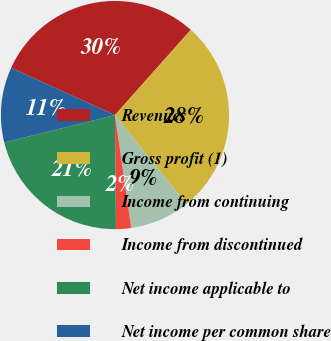Convert chart. <chart><loc_0><loc_0><loc_500><loc_500><pie_chart><fcel>Revenues<fcel>Gross profit (1)<fcel>Income from continuing<fcel>Income from discontinued<fcel>Net income applicable to<fcel>Net income per common share<nl><fcel>29.79%<fcel>27.66%<fcel>8.51%<fcel>2.13%<fcel>21.28%<fcel>10.64%<nl></chart> 